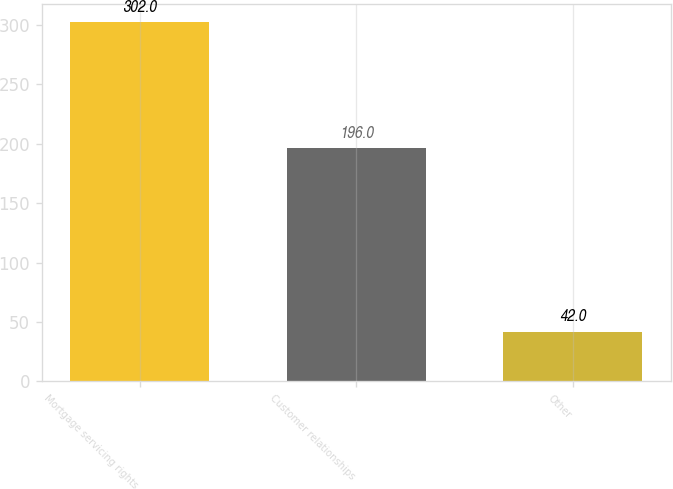Convert chart to OTSL. <chart><loc_0><loc_0><loc_500><loc_500><bar_chart><fcel>Mortgage servicing rights<fcel>Customer relationships<fcel>Other<nl><fcel>302<fcel>196<fcel>42<nl></chart> 